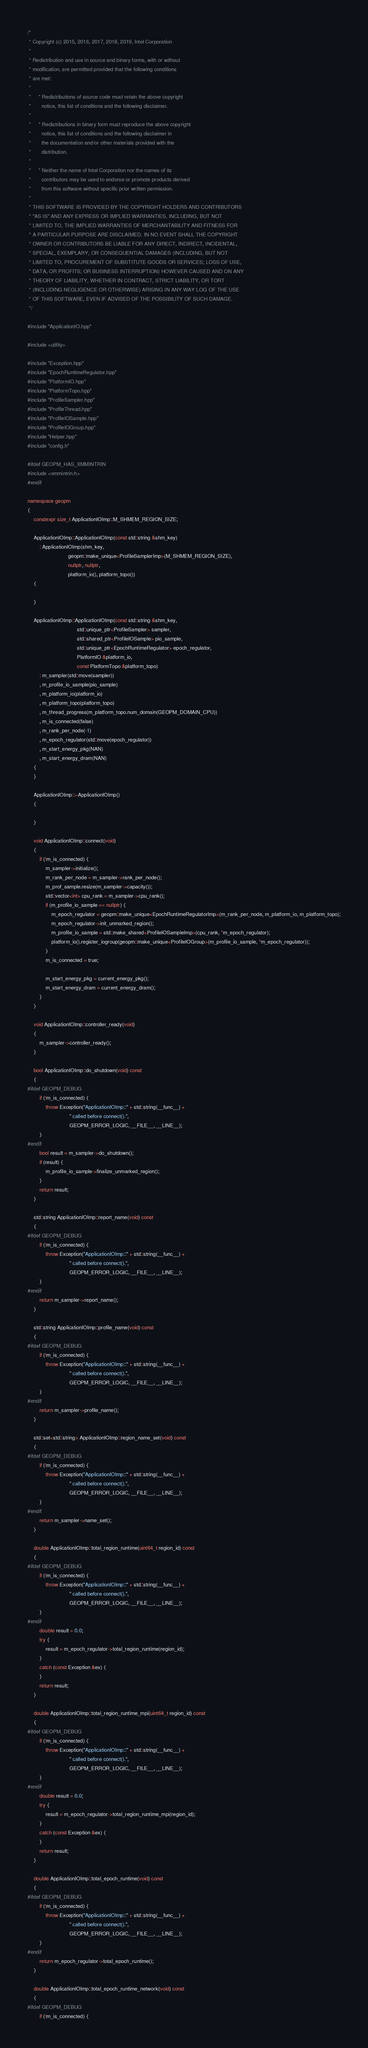Convert code to text. <code><loc_0><loc_0><loc_500><loc_500><_C++_>/*
 * Copyright (c) 2015, 2016, 2017, 2018, 2019, Intel Corporation
 *
 * Redistribution and use in source and binary forms, with or without
 * modification, are permitted provided that the following conditions
 * are met:
 *
 *     * Redistributions of source code must retain the above copyright
 *       notice, this list of conditions and the following disclaimer.
 *
 *     * Redistributions in binary form must reproduce the above copyright
 *       notice, this list of conditions and the following disclaimer in
 *       the documentation and/or other materials provided with the
 *       distribution.
 *
 *     * Neither the name of Intel Corporation nor the names of its
 *       contributors may be used to endorse or promote products derived
 *       from this software without specific prior written permission.
 *
 * THIS SOFTWARE IS PROVIDED BY THE COPYRIGHT HOLDERS AND CONTRIBUTORS
 * "AS IS" AND ANY EXPRESS OR IMPLIED WARRANTIES, INCLUDING, BUT NOT
 * LIMITED TO, THE IMPLIED WARRANTIES OF MERCHANTABILITY AND FITNESS FOR
 * A PARTICULAR PURPOSE ARE DISCLAIMED. IN NO EVENT SHALL THE COPYRIGHT
 * OWNER OR CONTRIBUTORS BE LIABLE FOR ANY DIRECT, INDIRECT, INCIDENTAL,
 * SPECIAL, EXEMPLARY, OR CONSEQUENTIAL DAMAGES (INCLUDING, BUT NOT
 * LIMITED TO, PROCUREMENT OF SUBSTITUTE GOODS OR SERVICES; LOSS OF USE,
 * DATA, OR PROFITS; OR BUSINESS INTERRUPTION) HOWEVER CAUSED AND ON ANY
 * THEORY OF LIABILITY, WHETHER IN CONTRACT, STRICT LIABILITY, OR TORT
 * (INCLUDING NEGLIGENCE OR OTHERWISE) ARISING IN ANY WAY LOG OF THE USE
 * OF THIS SOFTWARE, EVEN IF ADVISED OF THE POSSIBILITY OF SUCH DAMAGE.
 */

#include "ApplicationIO.hpp"

#include <utility>

#include "Exception.hpp"
#include "EpochRuntimeRegulator.hpp"
#include "PlatformIO.hpp"
#include "PlatformTopo.hpp"
#include "ProfileSampler.hpp"
#include "ProfileThread.hpp"
#include "ProfileIOSample.hpp"
#include "ProfileIOGroup.hpp"
#include "Helper.hpp"
#include "config.h"

#ifdef GEOPM_HAS_XMMINTRIN
#include <xmmintrin.h>
#endif

namespace geopm
{
    constexpr size_t ApplicationIOImp::M_SHMEM_REGION_SIZE;

    ApplicationIOImp::ApplicationIOImp(const std::string &shm_key)
        : ApplicationIOImp(shm_key,
                           geopm::make_unique<ProfileSamplerImp>(M_SHMEM_REGION_SIZE),
                           nullptr, nullptr,
                           platform_io(), platform_topo())
    {

    }

    ApplicationIOImp::ApplicationIOImp(const std::string &shm_key,
                                 std::unique_ptr<ProfileSampler> sampler,
                                 std::shared_ptr<ProfileIOSample> pio_sample,
                                 std::unique_ptr<EpochRuntimeRegulator> epoch_regulator,
                                 PlatformIO &platform_io,
                                 const PlatformTopo &platform_topo)
        : m_sampler(std::move(sampler))
        , m_profile_io_sample(pio_sample)
        , m_platform_io(platform_io)
        , m_platform_topo(platform_topo)
        , m_thread_progress(m_platform_topo.num_domain(GEOPM_DOMAIN_CPU))
        , m_is_connected(false)
        , m_rank_per_node(-1)
        , m_epoch_regulator(std::move(epoch_regulator))
        , m_start_energy_pkg(NAN)
        , m_start_energy_dram(NAN)
    {
    }

    ApplicationIOImp::~ApplicationIOImp()
    {

    }

    void ApplicationIOImp::connect(void)
    {
        if (!m_is_connected) {
            m_sampler->initialize();
            m_rank_per_node = m_sampler->rank_per_node();
            m_prof_sample.resize(m_sampler->capacity());
            std::vector<int> cpu_rank = m_sampler->cpu_rank();
            if (m_profile_io_sample == nullptr) {
                m_epoch_regulator = geopm::make_unique<EpochRuntimeRegulatorImp>(m_rank_per_node, m_platform_io, m_platform_topo);
                m_epoch_regulator->init_unmarked_region();
                m_profile_io_sample = std::make_shared<ProfileIOSampleImp>(cpu_rank, *m_epoch_regulator);
                platform_io().register_iogroup(geopm::make_unique<ProfileIOGroup>(m_profile_io_sample, *m_epoch_regulator));
            }
            m_is_connected = true;

            m_start_energy_pkg = current_energy_pkg();
            m_start_energy_dram = current_energy_dram();
        }
    }

    void ApplicationIOImp::controller_ready(void)
    {
        m_sampler->controller_ready();
    }

    bool ApplicationIOImp::do_shutdown(void) const
    {
#ifdef GEOPM_DEBUG
        if (!m_is_connected) {
            throw Exception("ApplicationIOImp::" + std::string(__func__) +
                            " called before connect().",
                            GEOPM_ERROR_LOGIC, __FILE__, __LINE__);
        }
#endif
        bool result = m_sampler->do_shutdown();
        if (result) {
            m_profile_io_sample->finalize_unmarked_region();
        }
        return result;
    }

    std::string ApplicationIOImp::report_name(void) const
    {
#ifdef GEOPM_DEBUG
        if (!m_is_connected) {
            throw Exception("ApplicationIOImp::" + std::string(__func__) +
                            " called before connect().",
                            GEOPM_ERROR_LOGIC, __FILE__, __LINE__);
        }
#endif
        return m_sampler->report_name();
    }

    std::string ApplicationIOImp::profile_name(void) const
    {
#ifdef GEOPM_DEBUG
        if (!m_is_connected) {
            throw Exception("ApplicationIOImp::" + std::string(__func__) +
                            " called before connect().",
                            GEOPM_ERROR_LOGIC, __FILE__, __LINE__);
        }
#endif
        return m_sampler->profile_name();
    }

    std::set<std::string> ApplicationIOImp::region_name_set(void) const
    {
#ifdef GEOPM_DEBUG
        if (!m_is_connected) {
            throw Exception("ApplicationIOImp::" + std::string(__func__) +
                            " called before connect().",
                            GEOPM_ERROR_LOGIC, __FILE__, __LINE__);
        }
#endif
        return m_sampler->name_set();
    }

    double ApplicationIOImp::total_region_runtime(uint64_t region_id) const
    {
#ifdef GEOPM_DEBUG
        if (!m_is_connected) {
            throw Exception("ApplicationIOImp::" + std::string(__func__) +
                            " called before connect().",
                            GEOPM_ERROR_LOGIC, __FILE__, __LINE__);
        }
#endif
        double result = 0.0;
        try {
            result = m_epoch_regulator->total_region_runtime(region_id);
        }
        catch (const Exception &ex) {
        }
        return result;
    }

    double ApplicationIOImp::total_region_runtime_mpi(uint64_t region_id) const
    {
#ifdef GEOPM_DEBUG
        if (!m_is_connected) {
            throw Exception("ApplicationIOImp::" + std::string(__func__) +
                            " called before connect().",
                            GEOPM_ERROR_LOGIC, __FILE__, __LINE__);
        }
#endif
        double result = 0.0;
        try {
            result = m_epoch_regulator->total_region_runtime_mpi(region_id);
        }
        catch (const Exception &ex) {
        }
        return result;
    }

    double ApplicationIOImp::total_epoch_runtime(void) const
    {
#ifdef GEOPM_DEBUG
        if (!m_is_connected) {
            throw Exception("ApplicationIOImp::" + std::string(__func__) +
                            " called before connect().",
                            GEOPM_ERROR_LOGIC, __FILE__, __LINE__);
        }
#endif
        return m_epoch_regulator->total_epoch_runtime();
    }

    double ApplicationIOImp::total_epoch_runtime_network(void) const
    {
#ifdef GEOPM_DEBUG
        if (!m_is_connected) {</code> 